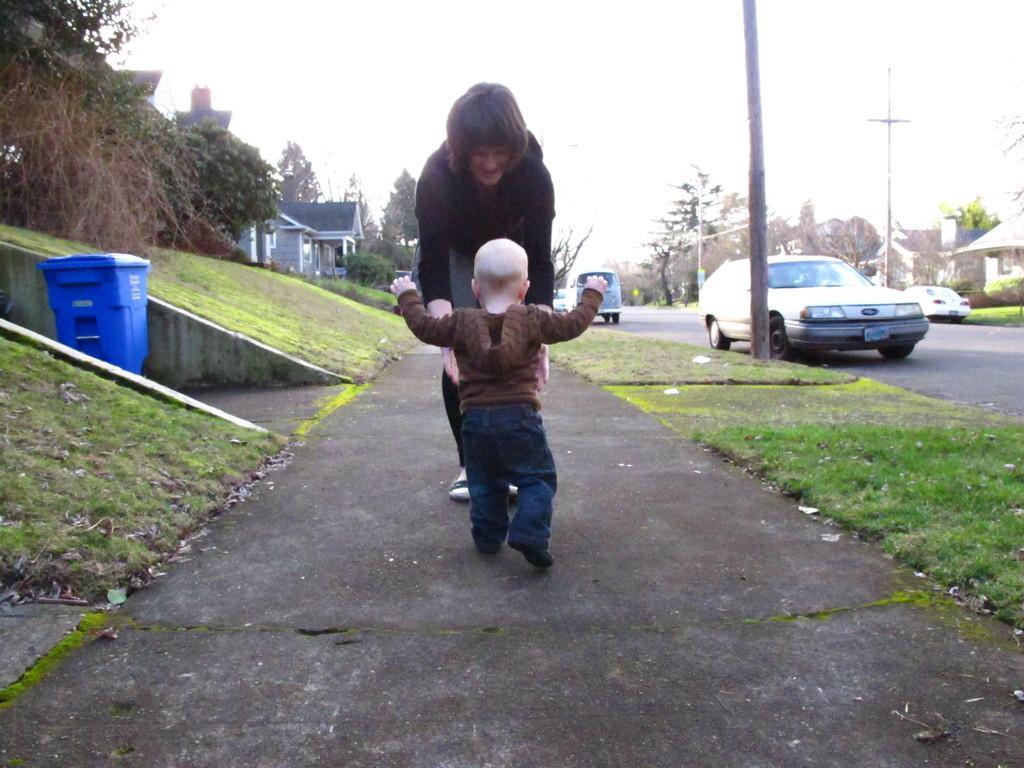Please provide a concise description of this image. In the center of the image we can see a lady and a kid. On the right we can see vehicles on the road. There are poles. On the left there are sheds and we can see a bin. In the background there are trees and sky. we can see grass. 